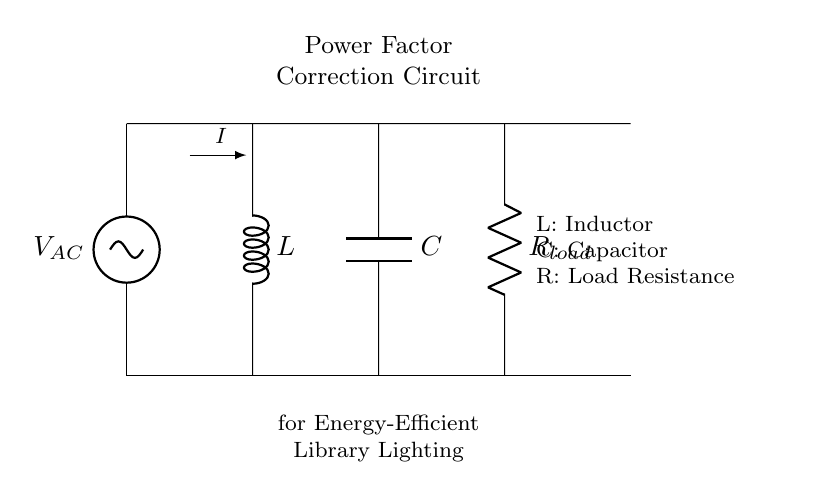What is the main purpose of this circuit? The circuit is designed for power factor correction, which improves the efficiency of the energy used by the lighting system.
Answer: Power factor correction What is the type of load represented in the circuit? The load is represented by a resistor, which indicates resistive load behavior in the circuit.
Answer: Resistor What component is used to store energy in this circuit? The component that stores energy is the capacitor, which charges and discharges based on the alternating current.
Answer: Capacitor Which component will help reduce the phase difference between voltage and current? The inductor is responsible for reducing the phase difference between voltage and current, thus improving the power factor.
Answer: Inductor What is the direction of current flow in this circuit? The direction of current flow is indicated by the arrow labeled "I", moving from the AC source through the circuit components.
Answer: From AC source to load How do the inductor and capacitor work together in this circuit? The inductor and capacitor work together by creating a resonance condition that helps in correcting the power factor, balancing the reactive power in the circuit.
Answer: They create resonance 